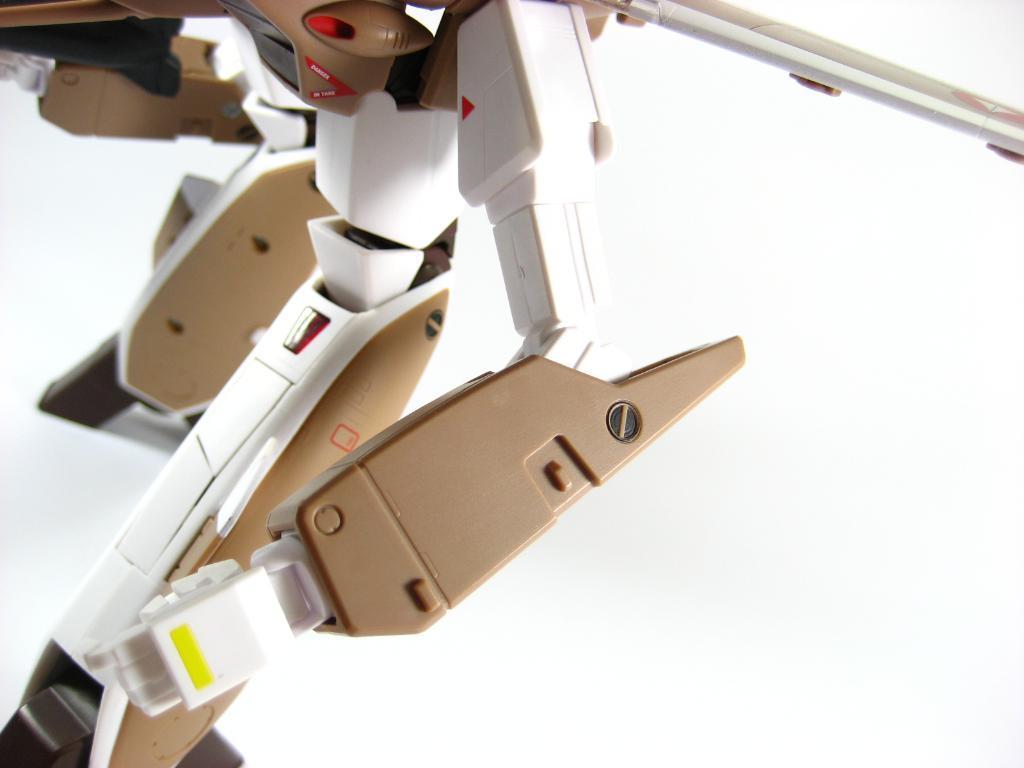How would you summarize this image in a sentence or two? In this image I can see some objects on the floor. This image looks like a photo frame. 